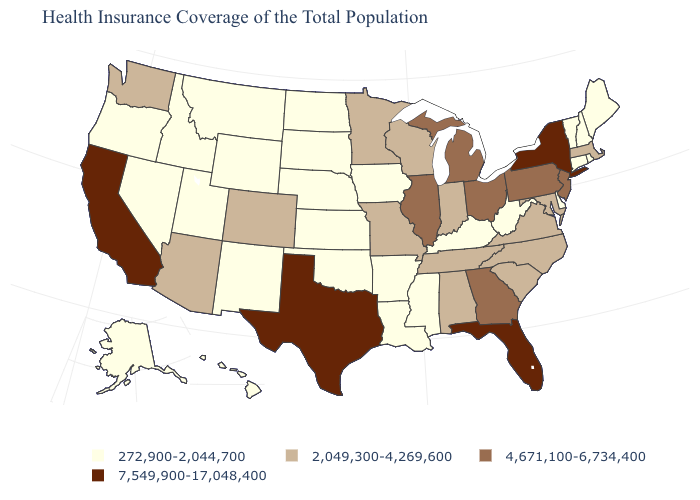Among the states that border West Virginia , does Kentucky have the lowest value?
Quick response, please. Yes. Among the states that border Kentucky , does Indiana have the lowest value?
Write a very short answer. No. Does the first symbol in the legend represent the smallest category?
Concise answer only. Yes. Which states have the lowest value in the South?
Be succinct. Arkansas, Delaware, Kentucky, Louisiana, Mississippi, Oklahoma, West Virginia. Which states have the lowest value in the USA?
Be succinct. Alaska, Arkansas, Connecticut, Delaware, Hawaii, Idaho, Iowa, Kansas, Kentucky, Louisiana, Maine, Mississippi, Montana, Nebraska, Nevada, New Hampshire, New Mexico, North Dakota, Oklahoma, Oregon, Rhode Island, South Dakota, Utah, Vermont, West Virginia, Wyoming. Among the states that border Nevada , does Idaho have the highest value?
Concise answer only. No. Does Louisiana have the same value as Ohio?
Write a very short answer. No. Does Rhode Island have the lowest value in the Northeast?
Short answer required. Yes. What is the value of Texas?
Quick response, please. 7,549,900-17,048,400. What is the value of Florida?
Give a very brief answer. 7,549,900-17,048,400. Does the first symbol in the legend represent the smallest category?
Answer briefly. Yes. Name the states that have a value in the range 272,900-2,044,700?
Short answer required. Alaska, Arkansas, Connecticut, Delaware, Hawaii, Idaho, Iowa, Kansas, Kentucky, Louisiana, Maine, Mississippi, Montana, Nebraska, Nevada, New Hampshire, New Mexico, North Dakota, Oklahoma, Oregon, Rhode Island, South Dakota, Utah, Vermont, West Virginia, Wyoming. Among the states that border Massachusetts , which have the highest value?
Keep it brief. New York. What is the lowest value in the USA?
Write a very short answer. 272,900-2,044,700. Name the states that have a value in the range 2,049,300-4,269,600?
Keep it brief. Alabama, Arizona, Colorado, Indiana, Maryland, Massachusetts, Minnesota, Missouri, North Carolina, South Carolina, Tennessee, Virginia, Washington, Wisconsin. 